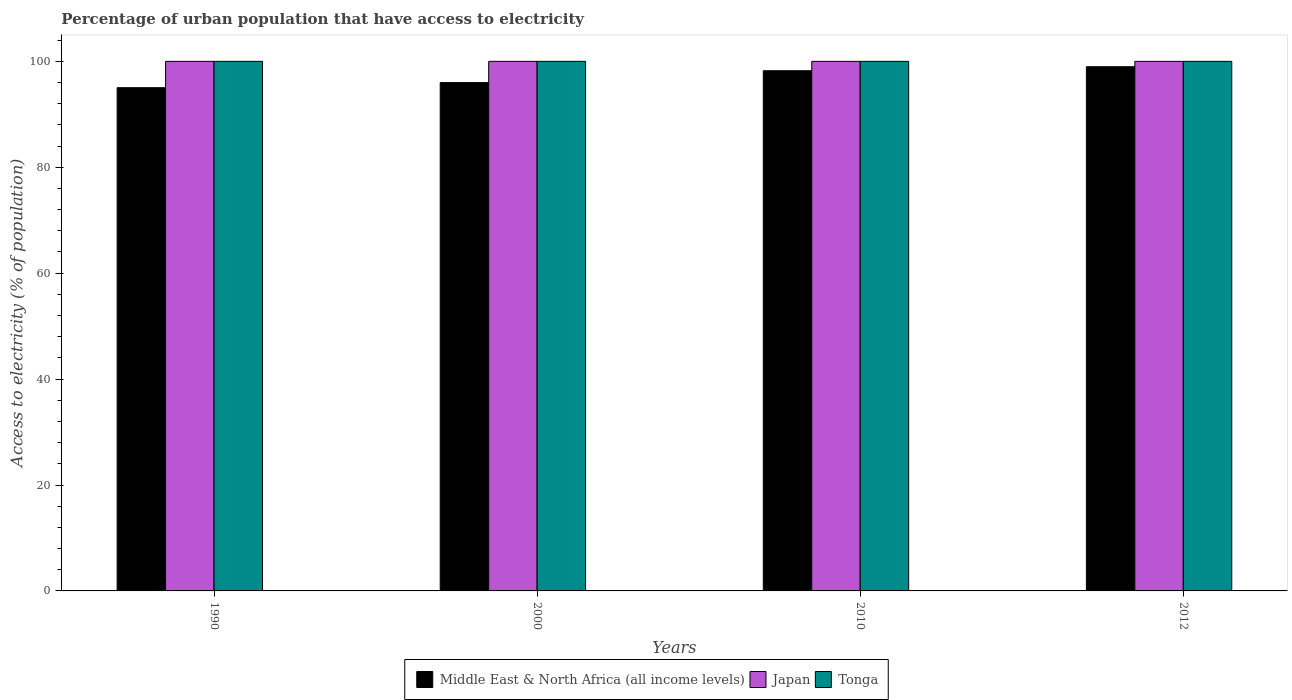How many groups of bars are there?
Your answer should be compact. 4. Are the number of bars on each tick of the X-axis equal?
Provide a succinct answer. Yes. How many bars are there on the 2nd tick from the right?
Offer a terse response. 3. What is the percentage of urban population that have access to electricity in Tonga in 2000?
Provide a succinct answer. 100. Across all years, what is the maximum percentage of urban population that have access to electricity in Middle East & North Africa (all income levels)?
Ensure brevity in your answer.  98.98. Across all years, what is the minimum percentage of urban population that have access to electricity in Middle East & North Africa (all income levels)?
Your response must be concise. 95.03. In which year was the percentage of urban population that have access to electricity in Middle East & North Africa (all income levels) maximum?
Provide a short and direct response. 2012. What is the total percentage of urban population that have access to electricity in Japan in the graph?
Provide a short and direct response. 400. What is the difference between the percentage of urban population that have access to electricity in Japan in 1990 and that in 2012?
Offer a terse response. 0. What is the difference between the percentage of urban population that have access to electricity in Tonga in 2010 and the percentage of urban population that have access to electricity in Middle East & North Africa (all income levels) in 1990?
Keep it short and to the point. 4.97. In the year 2010, what is the difference between the percentage of urban population that have access to electricity in Tonga and percentage of urban population that have access to electricity in Middle East & North Africa (all income levels)?
Provide a succinct answer. 1.77. What is the ratio of the percentage of urban population that have access to electricity in Middle East & North Africa (all income levels) in 2010 to that in 2012?
Ensure brevity in your answer.  0.99. What is the difference between the highest and the second highest percentage of urban population that have access to electricity in Tonga?
Provide a short and direct response. 0. What is the difference between the highest and the lowest percentage of urban population that have access to electricity in Middle East & North Africa (all income levels)?
Your answer should be very brief. 3.96. In how many years, is the percentage of urban population that have access to electricity in Japan greater than the average percentage of urban population that have access to electricity in Japan taken over all years?
Provide a short and direct response. 0. Is the sum of the percentage of urban population that have access to electricity in Tonga in 2000 and 2012 greater than the maximum percentage of urban population that have access to electricity in Middle East & North Africa (all income levels) across all years?
Your response must be concise. Yes. What does the 1st bar from the right in 2000 represents?
Give a very brief answer. Tonga. How many bars are there?
Offer a terse response. 12. Are the values on the major ticks of Y-axis written in scientific E-notation?
Offer a terse response. No. Where does the legend appear in the graph?
Give a very brief answer. Bottom center. How many legend labels are there?
Keep it short and to the point. 3. How are the legend labels stacked?
Your response must be concise. Horizontal. What is the title of the graph?
Offer a very short reply. Percentage of urban population that have access to electricity. Does "Oman" appear as one of the legend labels in the graph?
Your response must be concise. No. What is the label or title of the X-axis?
Ensure brevity in your answer.  Years. What is the label or title of the Y-axis?
Your answer should be very brief. Access to electricity (% of population). What is the Access to electricity (% of population) in Middle East & North Africa (all income levels) in 1990?
Provide a short and direct response. 95.03. What is the Access to electricity (% of population) in Japan in 1990?
Your answer should be compact. 100. What is the Access to electricity (% of population) in Middle East & North Africa (all income levels) in 2000?
Provide a short and direct response. 95.99. What is the Access to electricity (% of population) of Japan in 2000?
Make the answer very short. 100. What is the Access to electricity (% of population) in Tonga in 2000?
Provide a succinct answer. 100. What is the Access to electricity (% of population) of Middle East & North Africa (all income levels) in 2010?
Make the answer very short. 98.23. What is the Access to electricity (% of population) in Japan in 2010?
Your answer should be very brief. 100. What is the Access to electricity (% of population) of Middle East & North Africa (all income levels) in 2012?
Offer a terse response. 98.98. What is the Access to electricity (% of population) in Japan in 2012?
Offer a terse response. 100. What is the Access to electricity (% of population) of Tonga in 2012?
Ensure brevity in your answer.  100. Across all years, what is the maximum Access to electricity (% of population) in Middle East & North Africa (all income levels)?
Offer a very short reply. 98.98. Across all years, what is the maximum Access to electricity (% of population) of Tonga?
Your response must be concise. 100. Across all years, what is the minimum Access to electricity (% of population) in Middle East & North Africa (all income levels)?
Ensure brevity in your answer.  95.03. Across all years, what is the minimum Access to electricity (% of population) in Tonga?
Your response must be concise. 100. What is the total Access to electricity (% of population) in Middle East & North Africa (all income levels) in the graph?
Provide a succinct answer. 388.23. What is the total Access to electricity (% of population) of Japan in the graph?
Keep it short and to the point. 400. What is the total Access to electricity (% of population) of Tonga in the graph?
Your answer should be very brief. 400. What is the difference between the Access to electricity (% of population) of Middle East & North Africa (all income levels) in 1990 and that in 2000?
Your answer should be very brief. -0.96. What is the difference between the Access to electricity (% of population) of Tonga in 1990 and that in 2000?
Provide a short and direct response. 0. What is the difference between the Access to electricity (% of population) of Middle East & North Africa (all income levels) in 1990 and that in 2010?
Give a very brief answer. -3.2. What is the difference between the Access to electricity (% of population) of Tonga in 1990 and that in 2010?
Your response must be concise. 0. What is the difference between the Access to electricity (% of population) of Middle East & North Africa (all income levels) in 1990 and that in 2012?
Your response must be concise. -3.96. What is the difference between the Access to electricity (% of population) of Tonga in 1990 and that in 2012?
Make the answer very short. 0. What is the difference between the Access to electricity (% of population) of Middle East & North Africa (all income levels) in 2000 and that in 2010?
Offer a terse response. -2.24. What is the difference between the Access to electricity (% of population) in Tonga in 2000 and that in 2010?
Offer a terse response. 0. What is the difference between the Access to electricity (% of population) of Middle East & North Africa (all income levels) in 2000 and that in 2012?
Provide a short and direct response. -2.99. What is the difference between the Access to electricity (% of population) of Middle East & North Africa (all income levels) in 2010 and that in 2012?
Your answer should be very brief. -0.76. What is the difference between the Access to electricity (% of population) in Japan in 2010 and that in 2012?
Provide a succinct answer. 0. What is the difference between the Access to electricity (% of population) of Tonga in 2010 and that in 2012?
Offer a very short reply. 0. What is the difference between the Access to electricity (% of population) of Middle East & North Africa (all income levels) in 1990 and the Access to electricity (% of population) of Japan in 2000?
Provide a succinct answer. -4.97. What is the difference between the Access to electricity (% of population) in Middle East & North Africa (all income levels) in 1990 and the Access to electricity (% of population) in Tonga in 2000?
Ensure brevity in your answer.  -4.97. What is the difference between the Access to electricity (% of population) of Middle East & North Africa (all income levels) in 1990 and the Access to electricity (% of population) of Japan in 2010?
Offer a very short reply. -4.97. What is the difference between the Access to electricity (% of population) in Middle East & North Africa (all income levels) in 1990 and the Access to electricity (% of population) in Tonga in 2010?
Your response must be concise. -4.97. What is the difference between the Access to electricity (% of population) of Middle East & North Africa (all income levels) in 1990 and the Access to electricity (% of population) of Japan in 2012?
Keep it short and to the point. -4.97. What is the difference between the Access to electricity (% of population) of Middle East & North Africa (all income levels) in 1990 and the Access to electricity (% of population) of Tonga in 2012?
Offer a very short reply. -4.97. What is the difference between the Access to electricity (% of population) in Japan in 1990 and the Access to electricity (% of population) in Tonga in 2012?
Offer a very short reply. 0. What is the difference between the Access to electricity (% of population) of Middle East & North Africa (all income levels) in 2000 and the Access to electricity (% of population) of Japan in 2010?
Keep it short and to the point. -4.01. What is the difference between the Access to electricity (% of population) of Middle East & North Africa (all income levels) in 2000 and the Access to electricity (% of population) of Tonga in 2010?
Your response must be concise. -4.01. What is the difference between the Access to electricity (% of population) of Japan in 2000 and the Access to electricity (% of population) of Tonga in 2010?
Your response must be concise. 0. What is the difference between the Access to electricity (% of population) in Middle East & North Africa (all income levels) in 2000 and the Access to electricity (% of population) in Japan in 2012?
Ensure brevity in your answer.  -4.01. What is the difference between the Access to electricity (% of population) in Middle East & North Africa (all income levels) in 2000 and the Access to electricity (% of population) in Tonga in 2012?
Your response must be concise. -4.01. What is the difference between the Access to electricity (% of population) of Japan in 2000 and the Access to electricity (% of population) of Tonga in 2012?
Make the answer very short. 0. What is the difference between the Access to electricity (% of population) of Middle East & North Africa (all income levels) in 2010 and the Access to electricity (% of population) of Japan in 2012?
Ensure brevity in your answer.  -1.77. What is the difference between the Access to electricity (% of population) in Middle East & North Africa (all income levels) in 2010 and the Access to electricity (% of population) in Tonga in 2012?
Keep it short and to the point. -1.77. What is the difference between the Access to electricity (% of population) of Japan in 2010 and the Access to electricity (% of population) of Tonga in 2012?
Make the answer very short. 0. What is the average Access to electricity (% of population) of Middle East & North Africa (all income levels) per year?
Make the answer very short. 97.06. What is the average Access to electricity (% of population) of Japan per year?
Ensure brevity in your answer.  100. What is the average Access to electricity (% of population) in Tonga per year?
Offer a very short reply. 100. In the year 1990, what is the difference between the Access to electricity (% of population) in Middle East & North Africa (all income levels) and Access to electricity (% of population) in Japan?
Make the answer very short. -4.97. In the year 1990, what is the difference between the Access to electricity (% of population) of Middle East & North Africa (all income levels) and Access to electricity (% of population) of Tonga?
Provide a short and direct response. -4.97. In the year 2000, what is the difference between the Access to electricity (% of population) of Middle East & North Africa (all income levels) and Access to electricity (% of population) of Japan?
Your answer should be very brief. -4.01. In the year 2000, what is the difference between the Access to electricity (% of population) of Middle East & North Africa (all income levels) and Access to electricity (% of population) of Tonga?
Your response must be concise. -4.01. In the year 2010, what is the difference between the Access to electricity (% of population) in Middle East & North Africa (all income levels) and Access to electricity (% of population) in Japan?
Make the answer very short. -1.77. In the year 2010, what is the difference between the Access to electricity (% of population) of Middle East & North Africa (all income levels) and Access to electricity (% of population) of Tonga?
Ensure brevity in your answer.  -1.77. In the year 2010, what is the difference between the Access to electricity (% of population) in Japan and Access to electricity (% of population) in Tonga?
Your response must be concise. 0. In the year 2012, what is the difference between the Access to electricity (% of population) in Middle East & North Africa (all income levels) and Access to electricity (% of population) in Japan?
Provide a short and direct response. -1.02. In the year 2012, what is the difference between the Access to electricity (% of population) in Middle East & North Africa (all income levels) and Access to electricity (% of population) in Tonga?
Provide a short and direct response. -1.02. In the year 2012, what is the difference between the Access to electricity (% of population) of Japan and Access to electricity (% of population) of Tonga?
Your answer should be compact. 0. What is the ratio of the Access to electricity (% of population) of Middle East & North Africa (all income levels) in 1990 to that in 2000?
Offer a terse response. 0.99. What is the ratio of the Access to electricity (% of population) in Japan in 1990 to that in 2000?
Ensure brevity in your answer.  1. What is the ratio of the Access to electricity (% of population) in Middle East & North Africa (all income levels) in 1990 to that in 2010?
Ensure brevity in your answer.  0.97. What is the ratio of the Access to electricity (% of population) in Tonga in 1990 to that in 2010?
Ensure brevity in your answer.  1. What is the ratio of the Access to electricity (% of population) of Japan in 1990 to that in 2012?
Give a very brief answer. 1. What is the ratio of the Access to electricity (% of population) in Middle East & North Africa (all income levels) in 2000 to that in 2010?
Offer a terse response. 0.98. What is the ratio of the Access to electricity (% of population) of Tonga in 2000 to that in 2010?
Offer a very short reply. 1. What is the ratio of the Access to electricity (% of population) in Middle East & North Africa (all income levels) in 2000 to that in 2012?
Your answer should be very brief. 0.97. What is the ratio of the Access to electricity (% of population) of Japan in 2000 to that in 2012?
Offer a very short reply. 1. What is the ratio of the Access to electricity (% of population) of Tonga in 2000 to that in 2012?
Your response must be concise. 1. What is the ratio of the Access to electricity (% of population) of Middle East & North Africa (all income levels) in 2010 to that in 2012?
Make the answer very short. 0.99. What is the ratio of the Access to electricity (% of population) in Japan in 2010 to that in 2012?
Provide a short and direct response. 1. What is the difference between the highest and the second highest Access to electricity (% of population) in Middle East & North Africa (all income levels)?
Your answer should be compact. 0.76. What is the difference between the highest and the second highest Access to electricity (% of population) in Japan?
Make the answer very short. 0. What is the difference between the highest and the second highest Access to electricity (% of population) in Tonga?
Your response must be concise. 0. What is the difference between the highest and the lowest Access to electricity (% of population) of Middle East & North Africa (all income levels)?
Your response must be concise. 3.96. 